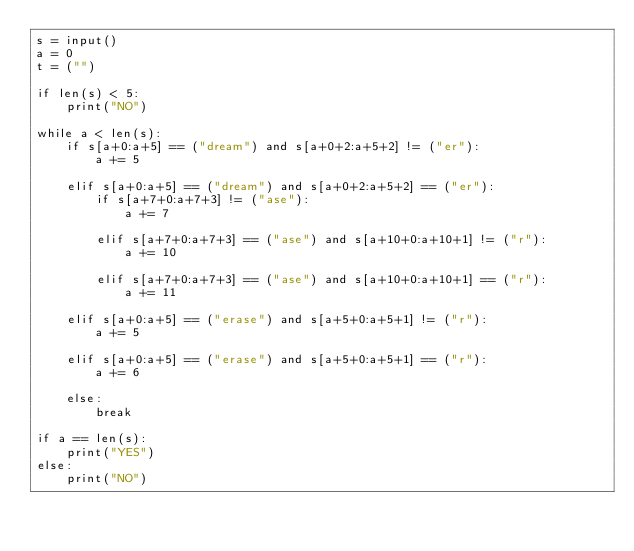Convert code to text. <code><loc_0><loc_0><loc_500><loc_500><_Python_>s = input()
a = 0
t = ("")

if len(s) < 5:
    print("NO")

while a < len(s):
    if s[a+0:a+5] == ("dream") and s[a+0+2:a+5+2] != ("er"):
        a += 5

    elif s[a+0:a+5] == ("dream") and s[a+0+2:a+5+2] == ("er"):
        if s[a+7+0:a+7+3] != ("ase"):
            a += 7

        elif s[a+7+0:a+7+3] == ("ase") and s[a+10+0:a+10+1] != ("r"):
            a += 10

        elif s[a+7+0:a+7+3] == ("ase") and s[a+10+0:a+10+1] == ("r"):
            a += 11

    elif s[a+0:a+5] == ("erase") and s[a+5+0:a+5+1] != ("r"):
        a += 5

    elif s[a+0:a+5] == ("erase") and s[a+5+0:a+5+1] == ("r"):
        a += 6

    else:
        break

if a == len(s):
    print("YES")
else:
    print("NO")
</code> 